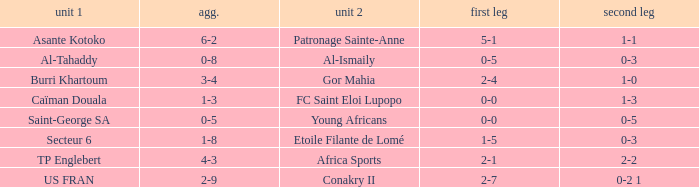Which team lost 0-3 and 0-5? Al-Tahaddy. 